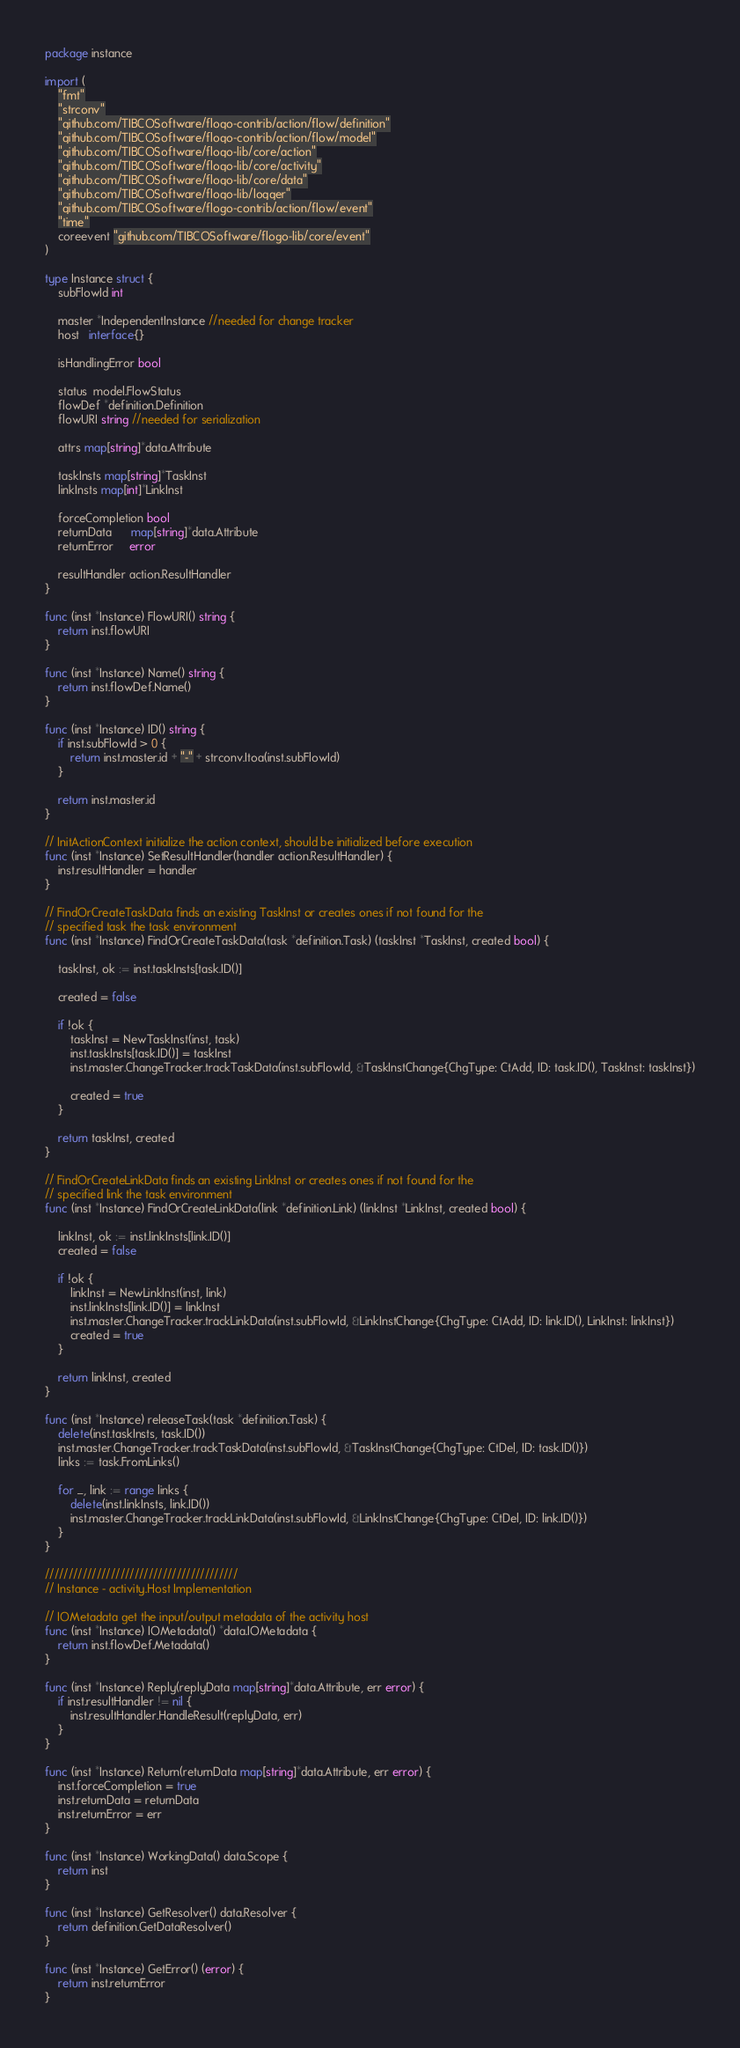Convert code to text. <code><loc_0><loc_0><loc_500><loc_500><_Go_>package instance

import (
	"fmt"
	"strconv"
	"github.com/TIBCOSoftware/flogo-contrib/action/flow/definition"
	"github.com/TIBCOSoftware/flogo-contrib/action/flow/model"
	"github.com/TIBCOSoftware/flogo-lib/core/action"
	"github.com/TIBCOSoftware/flogo-lib/core/activity"
	"github.com/TIBCOSoftware/flogo-lib/core/data"
	"github.com/TIBCOSoftware/flogo-lib/logger"
	"github.com/TIBCOSoftware/flogo-contrib/action/flow/event"
	"time"
	coreevent "github.com/TIBCOSoftware/flogo-lib/core/event"
)

type Instance struct {
	subFlowId int

	master *IndependentInstance //needed for change tracker
	host   interface{}

	isHandlingError bool

	status  model.FlowStatus
	flowDef *definition.Definition
	flowURI string //needed for serialization

	attrs map[string]*data.Attribute

	taskInsts map[string]*TaskInst
	linkInsts map[int]*LinkInst

	forceCompletion bool
	returnData      map[string]*data.Attribute
	returnError     error

	resultHandler action.ResultHandler
}

func (inst *Instance) FlowURI() string {
	return inst.flowURI
}

func (inst *Instance) Name() string {
	return inst.flowDef.Name()
}

func (inst *Instance) ID() string {
	if inst.subFlowId > 0 {
		return inst.master.id + "-" + strconv.Itoa(inst.subFlowId)
	}

	return inst.master.id
}

// InitActionContext initialize the action context, should be initialized before execution
func (inst *Instance) SetResultHandler(handler action.ResultHandler) {
	inst.resultHandler = handler
}

// FindOrCreateTaskData finds an existing TaskInst or creates ones if not found for the
// specified task the task environment
func (inst *Instance) FindOrCreateTaskData(task *definition.Task) (taskInst *TaskInst, created bool) {

	taskInst, ok := inst.taskInsts[task.ID()]

	created = false

	if !ok {
		taskInst = NewTaskInst(inst, task)
		inst.taskInsts[task.ID()] = taskInst
		inst.master.ChangeTracker.trackTaskData(inst.subFlowId, &TaskInstChange{ChgType: CtAdd, ID: task.ID(), TaskInst: taskInst})

		created = true
	}

	return taskInst, created
}

// FindOrCreateLinkData finds an existing LinkInst or creates ones if not found for the
// specified link the task environment
func (inst *Instance) FindOrCreateLinkData(link *definition.Link) (linkInst *LinkInst, created bool) {

	linkInst, ok := inst.linkInsts[link.ID()]
	created = false

	if !ok {
		linkInst = NewLinkInst(inst, link)
		inst.linkInsts[link.ID()] = linkInst
		inst.master.ChangeTracker.trackLinkData(inst.subFlowId, &LinkInstChange{ChgType: CtAdd, ID: link.ID(), LinkInst: linkInst})
		created = true
	}

	return linkInst, created
}

func (inst *Instance) releaseTask(task *definition.Task) {
	delete(inst.taskInsts, task.ID())
	inst.master.ChangeTracker.trackTaskData(inst.subFlowId, &TaskInstChange{ChgType: CtDel, ID: task.ID()})
	links := task.FromLinks()

	for _, link := range links {
		delete(inst.linkInsts, link.ID())
		inst.master.ChangeTracker.trackLinkData(inst.subFlowId, &LinkInstChange{ChgType: CtDel, ID: link.ID()})
	}
}

/////////////////////////////////////////
// Instance - activity.Host Implementation

// IOMetadata get the input/output metadata of the activity host
func (inst *Instance) IOMetadata() *data.IOMetadata {
	return inst.flowDef.Metadata()
}

func (inst *Instance) Reply(replyData map[string]*data.Attribute, err error) {
	if inst.resultHandler != nil {
		inst.resultHandler.HandleResult(replyData, err)
	}
}

func (inst *Instance) Return(returnData map[string]*data.Attribute, err error) {
	inst.forceCompletion = true
	inst.returnData = returnData
	inst.returnError = err
}

func (inst *Instance) WorkingData() data.Scope {
	return inst
}

func (inst *Instance) GetResolver() data.Resolver {
	return definition.GetDataResolver()
}

func (inst *Instance) GetError() (error) {
	return inst.returnError
}
</code> 